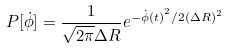<formula> <loc_0><loc_0><loc_500><loc_500>P [ \dot { \phi } ] = \frac { 1 } { \sqrt { 2 \pi } \Delta R } e ^ { - { \dot { \phi } ( t ) } ^ { 2 } / { 2 ( \Delta R ) ^ { 2 } } }</formula> 